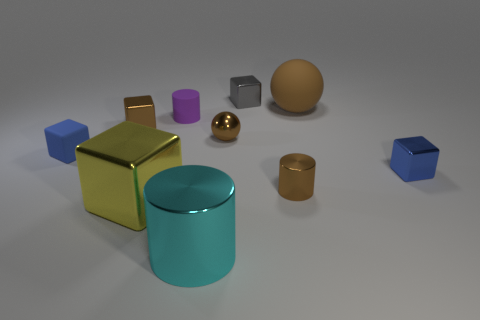Can you tell which of the objects in the image are of similar size? Certainly! The blue cube to the right of the large golden cube and the tiny gold cylinder in front of the matte sphere appear to have similar dimensions. 